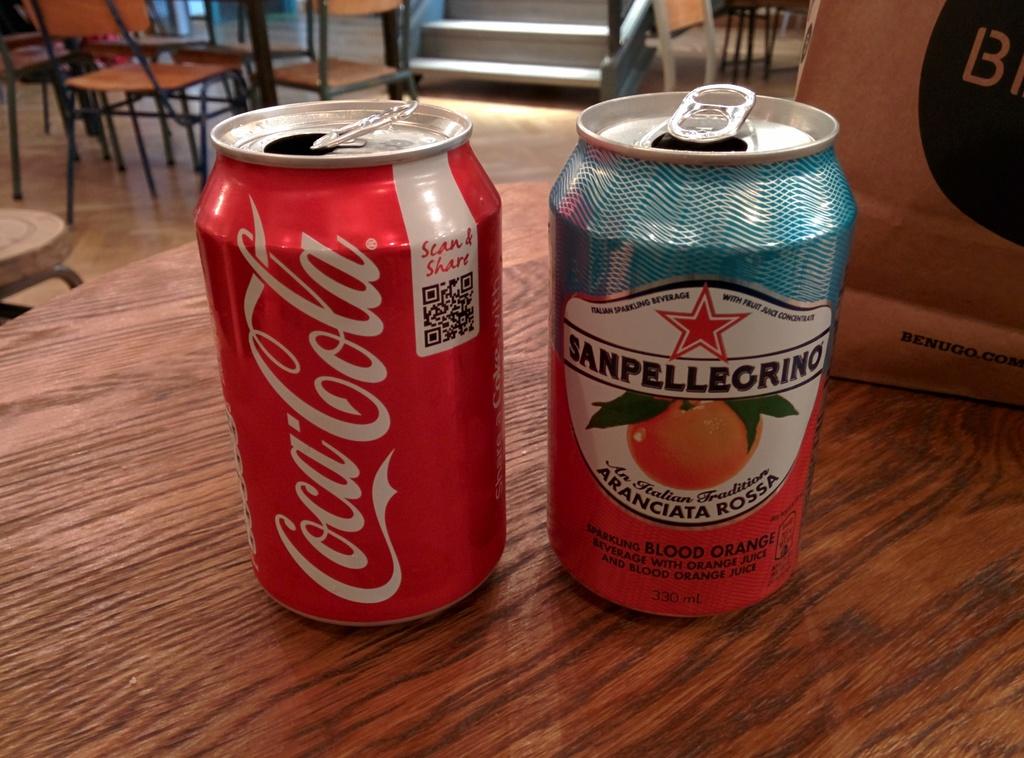What brand is on the can on the right?
Your response must be concise. Sanpellegrino. 